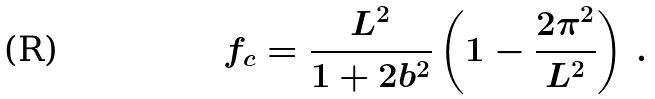<formula> <loc_0><loc_0><loc_500><loc_500>f _ { c } = \frac { L ^ { 2 } } { 1 + 2 b ^ { 2 } } \left ( 1 - \frac { 2 \pi ^ { 2 } } { L ^ { 2 } } \right ) \, .</formula> 